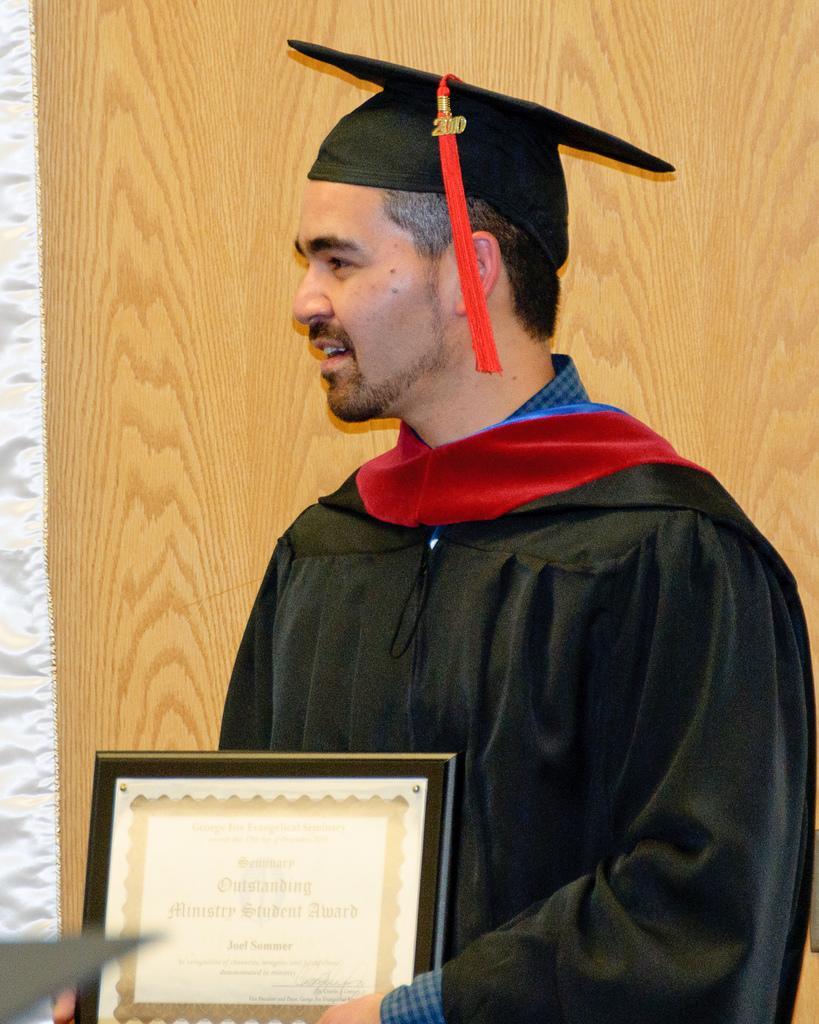In one or two sentences, can you explain what this image depicts? In the picture we can see a man standing near the wooden wall and holding a certificate with a frame to it. 